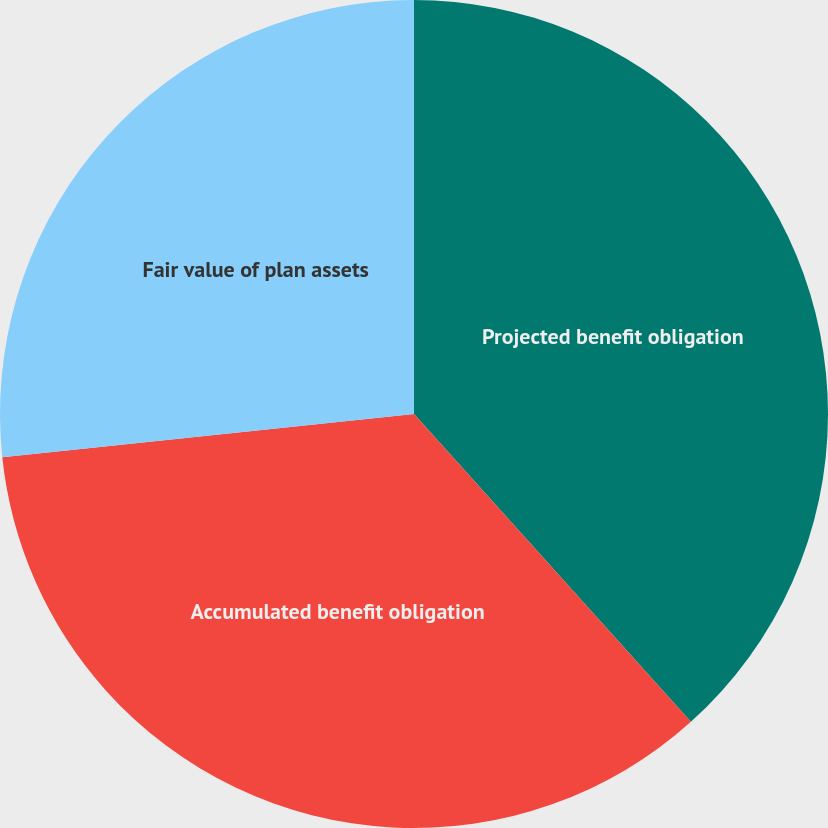Convert chart. <chart><loc_0><loc_0><loc_500><loc_500><pie_chart><fcel>Projected benefit obligation<fcel>Accumulated benefit obligation<fcel>Fair value of plan assets<nl><fcel>38.34%<fcel>34.99%<fcel>26.67%<nl></chart> 